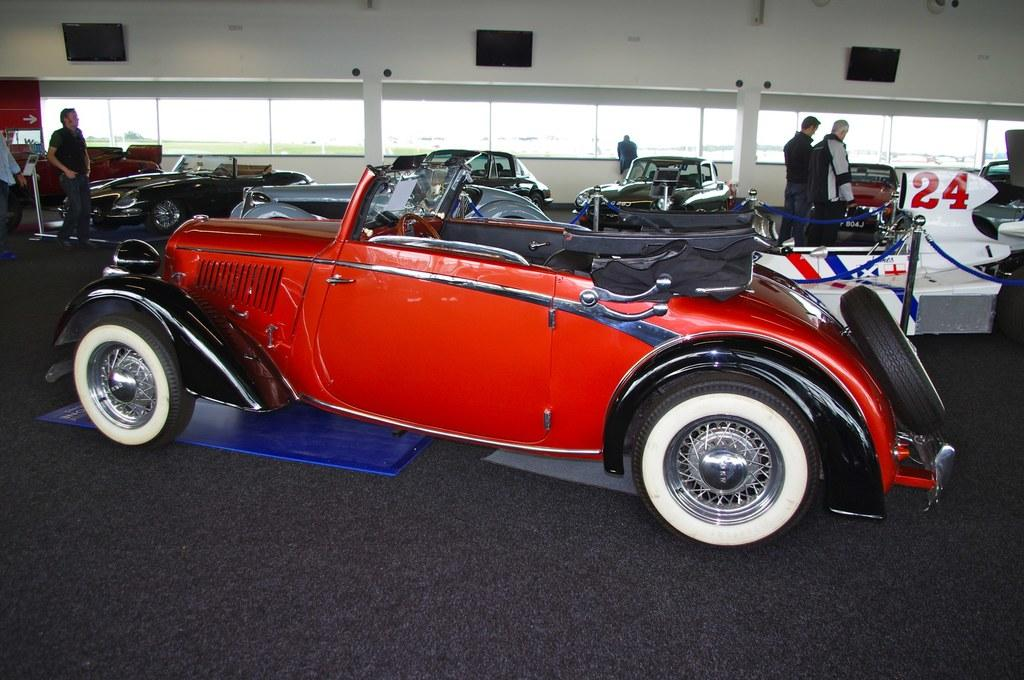What is the main subject of the image? The main subject of the image is a collection of cars. Where are the cars located? The cars are in a showroom. Are there any people present in the image? Yes, there are people standing around the cars. What can be seen in the background of the image? The background of the image includes windows. How many sinks can be seen in the image? There are no sinks present in the image; it features a collection of cars in a showroom. What type of bulb is used to illuminate the cars in the image? There is no specific information about the type of bulb used to illuminate the cars in the image. 